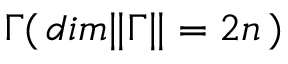<formula> <loc_0><loc_0><loc_500><loc_500>{ \Gamma } ( \, d i m \| \Gamma \| = 2 n \, )</formula> 